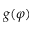<formula> <loc_0><loc_0><loc_500><loc_500>g ( \varphi )</formula> 